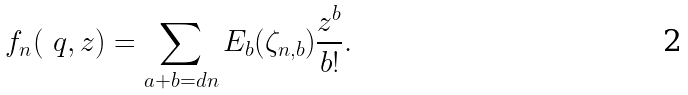Convert formula to latex. <formula><loc_0><loc_0><loc_500><loc_500>\ f _ { n } ( \ q , z ) = \sum _ { a + b = d n } E _ { b } ( \zeta _ { n , b } ) \frac { z ^ { b } } { b ! } .</formula> 